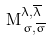Convert formula to latex. <formula><loc_0><loc_0><loc_500><loc_500>M _ { \, \sigma , \overline { \sigma } } ^ { \lambda , \overline { \lambda } }</formula> 